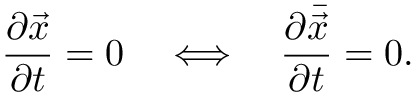Convert formula to latex. <formula><loc_0><loc_0><loc_500><loc_500>\frac { \partial \vec { x } } { \partial t } = 0 \quad \Longleftrightarrow \quad \frac { \partial \bar { \vec { x } } } { \partial t } = 0 .</formula> 